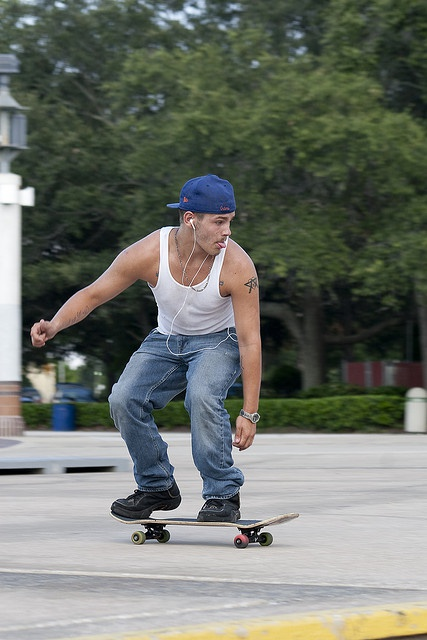Describe the objects in this image and their specific colors. I can see people in gray, black, darkgray, and lightgray tones and skateboard in gray, black, lightgray, and darkgray tones in this image. 